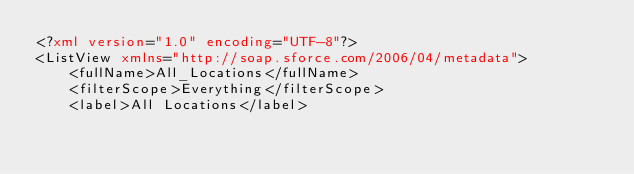Convert code to text. <code><loc_0><loc_0><loc_500><loc_500><_XML_><?xml version="1.0" encoding="UTF-8"?>
<ListView xmlns="http://soap.sforce.com/2006/04/metadata">
    <fullName>All_Locations</fullName>
    <filterScope>Everything</filterScope>
    <label>All Locations</label></code> 